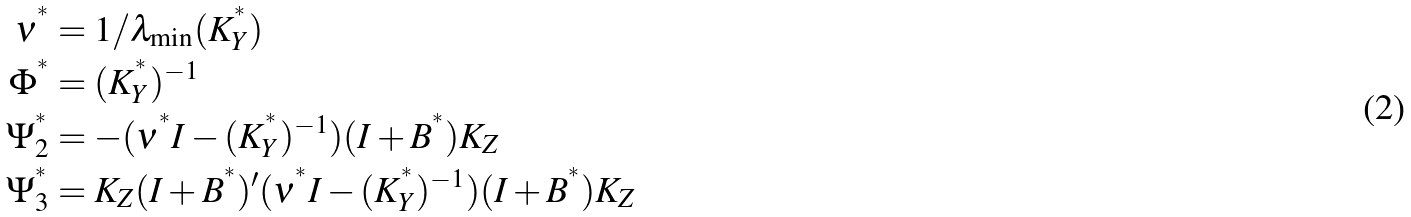<formula> <loc_0><loc_0><loc_500><loc_500>\nu ^ { ^ { * } } & = 1 / \lambda _ { \min } ( K _ { Y } ^ { ^ { * } } ) \\ \Phi ^ { ^ { * } } & = ( K _ { Y } ^ { ^ { * } } ) ^ { - 1 } \\ \Psi _ { 2 } ^ { ^ { * } } & = - ( \nu ^ { ^ { * } } I - ( K _ { Y } ^ { ^ { * } } ) ^ { - 1 } ) ( I + B ^ { ^ { * } } ) K _ { Z } \\ \Psi _ { 3 } ^ { ^ { * } } & = K _ { Z } ( I + B ^ { ^ { * } } ) ^ { \prime } ( \nu ^ { ^ { * } } I - ( K _ { Y } ^ { ^ { * } } ) ^ { - 1 } ) ( I + B ^ { ^ { * } } ) K _ { Z }</formula> 